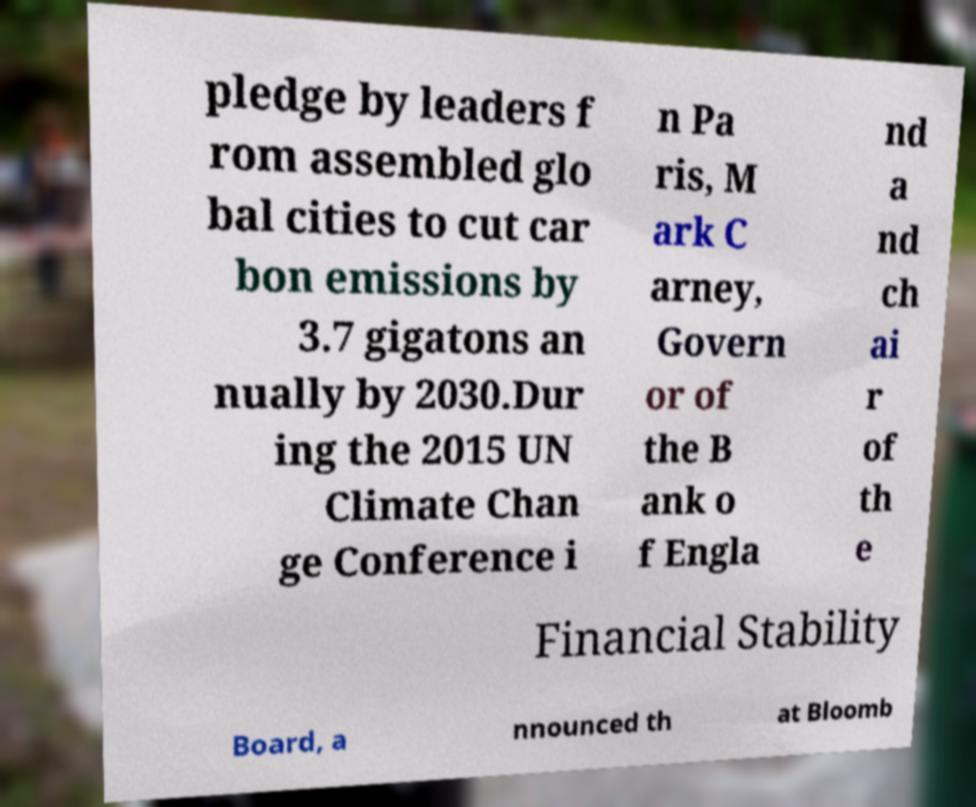Can you accurately transcribe the text from the provided image for me? pledge by leaders f rom assembled glo bal cities to cut car bon emissions by 3.7 gigatons an nually by 2030.Dur ing the 2015 UN Climate Chan ge Conference i n Pa ris, M ark C arney, Govern or of the B ank o f Engla nd a nd ch ai r of th e Financial Stability Board, a nnounced th at Bloomb 